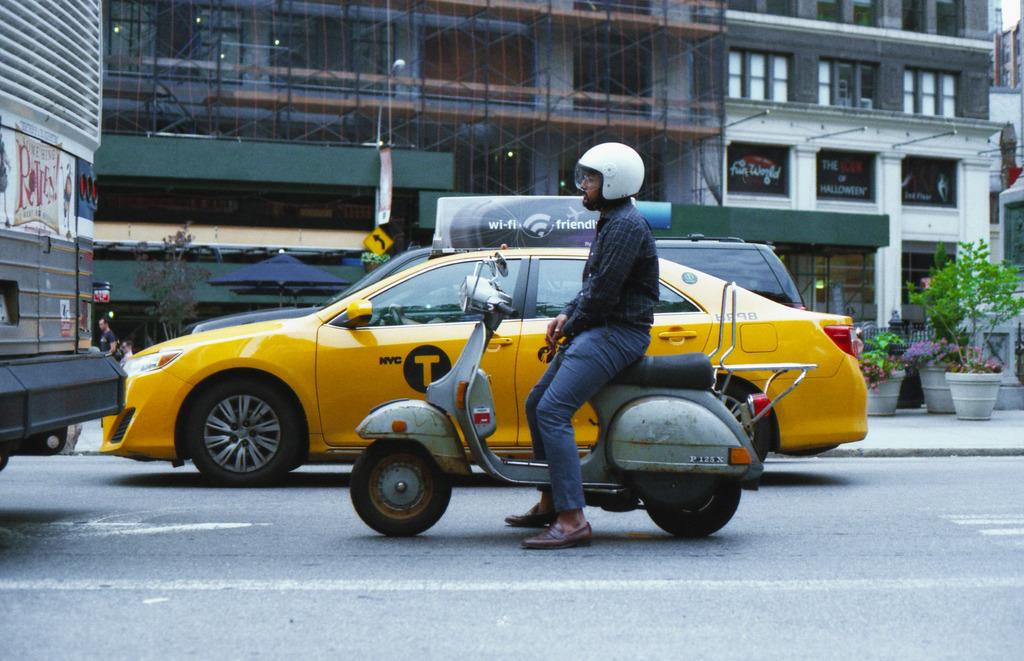What letter is on the yellow car?
Your answer should be very brief. T. What is the identification text on the scooter?
Your answer should be very brief. P125x. 